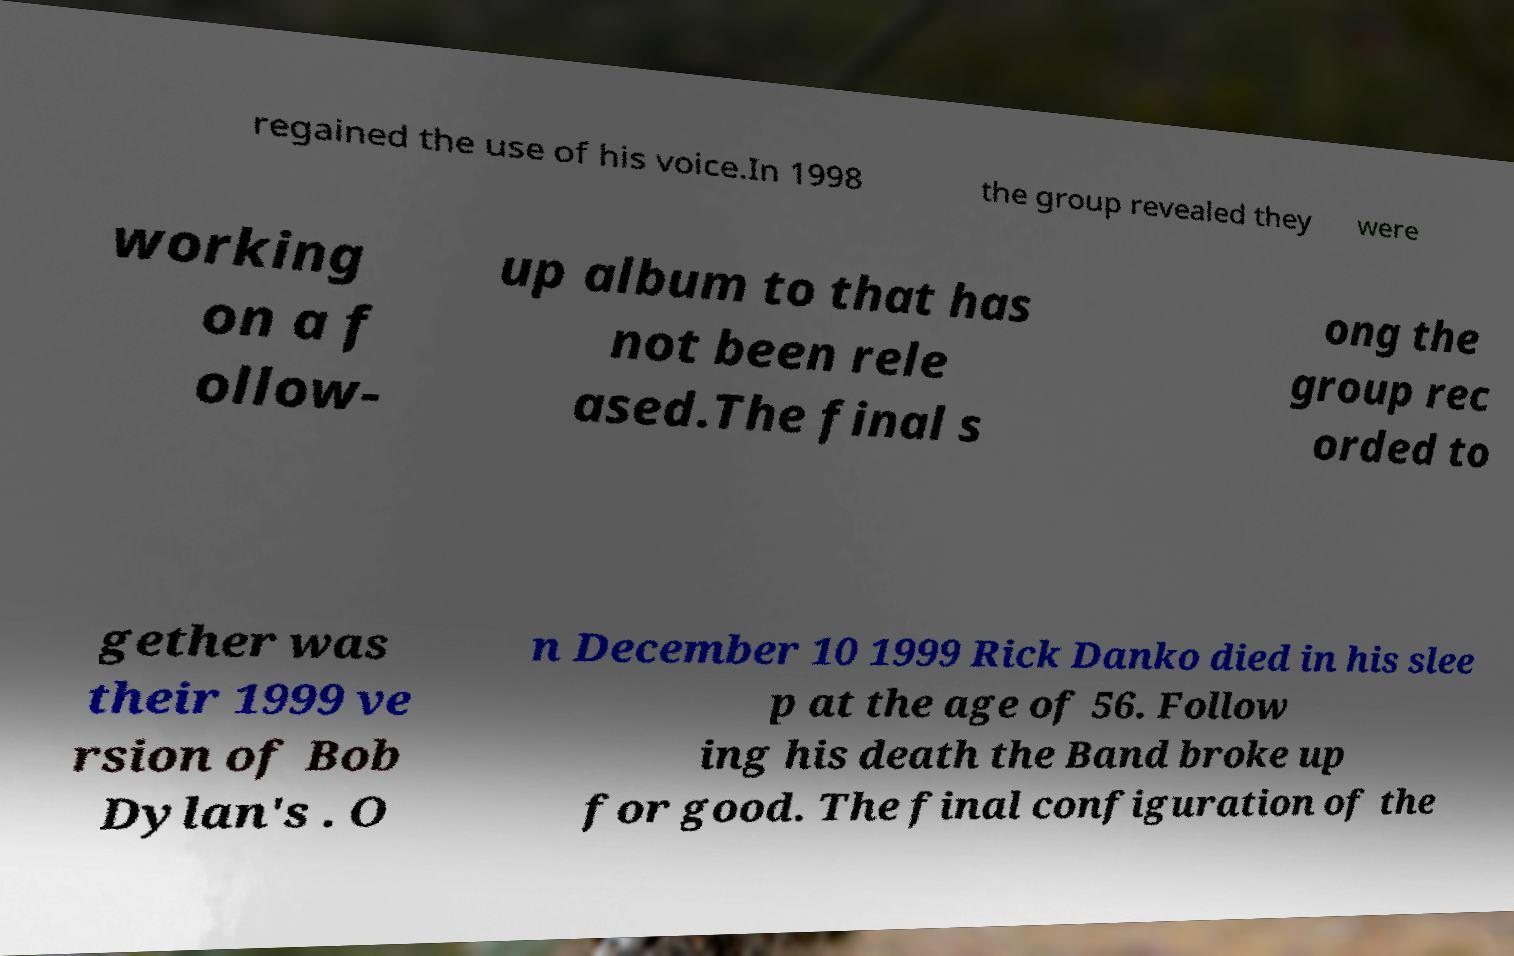Please identify and transcribe the text found in this image. regained the use of his voice.In 1998 the group revealed they were working on a f ollow- up album to that has not been rele ased.The final s ong the group rec orded to gether was their 1999 ve rsion of Bob Dylan's . O n December 10 1999 Rick Danko died in his slee p at the age of 56. Follow ing his death the Band broke up for good. The final configuration of the 